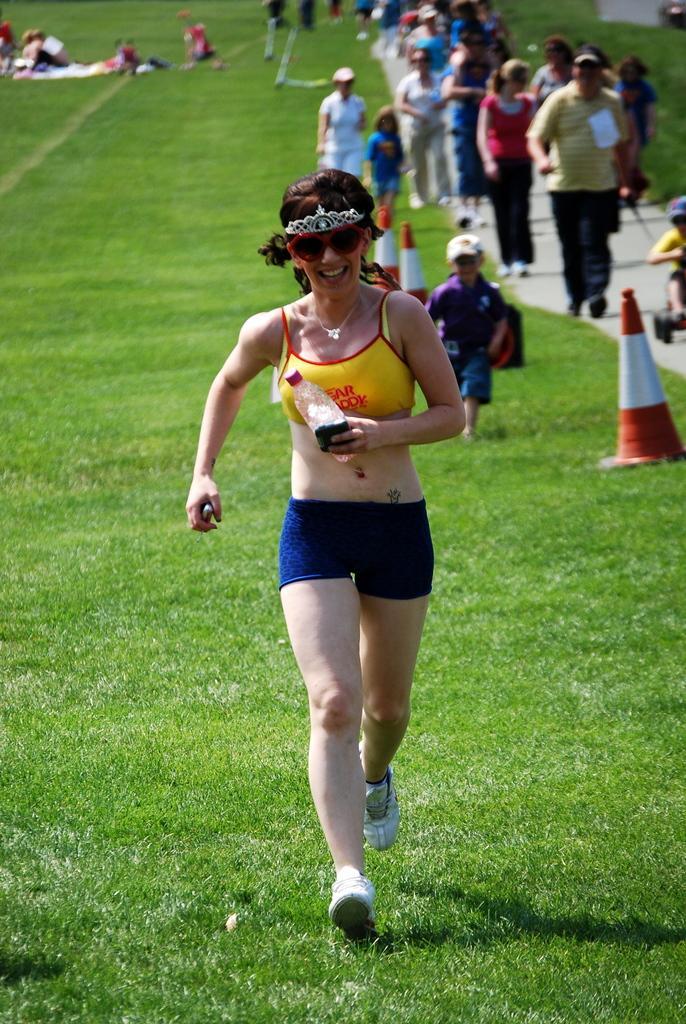In one or two sentences, can you explain what this image depicts? This picture describes about group of people, in the middle of the image we can see a woman, she is holding a bottle and she is running on the grass, in the background we can see few road divider cones. 